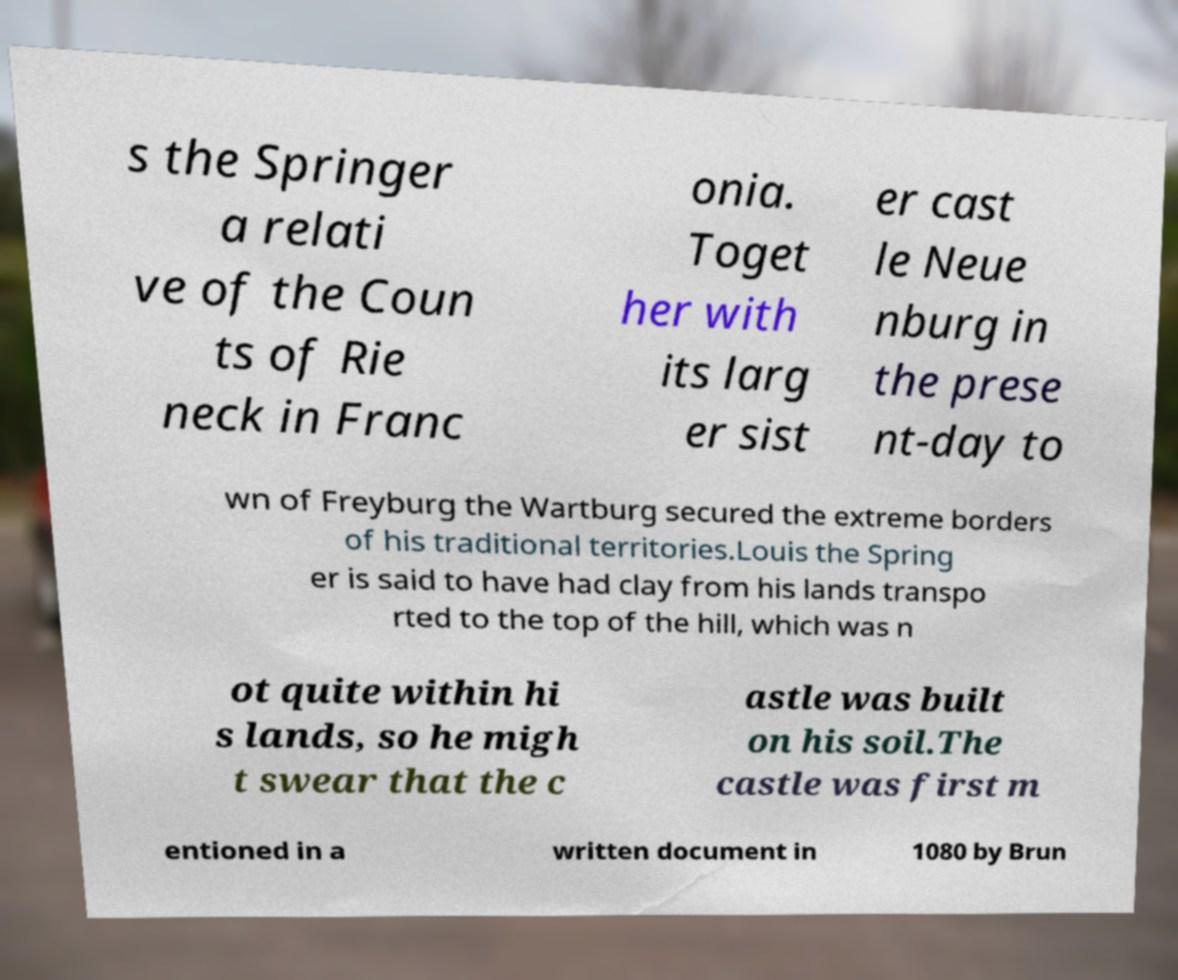Can you read and provide the text displayed in the image?This photo seems to have some interesting text. Can you extract and type it out for me? s the Springer a relati ve of the Coun ts of Rie neck in Franc onia. Toget her with its larg er sist er cast le Neue nburg in the prese nt-day to wn of Freyburg the Wartburg secured the extreme borders of his traditional territories.Louis the Spring er is said to have had clay from his lands transpo rted to the top of the hill, which was n ot quite within hi s lands, so he migh t swear that the c astle was built on his soil.The castle was first m entioned in a written document in 1080 by Brun 